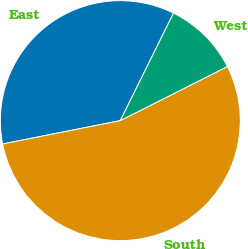Convert chart to OTSL. <chart><loc_0><loc_0><loc_500><loc_500><pie_chart><fcel>East<fcel>South<fcel>West<nl><fcel>35.43%<fcel>54.33%<fcel>10.24%<nl></chart> 